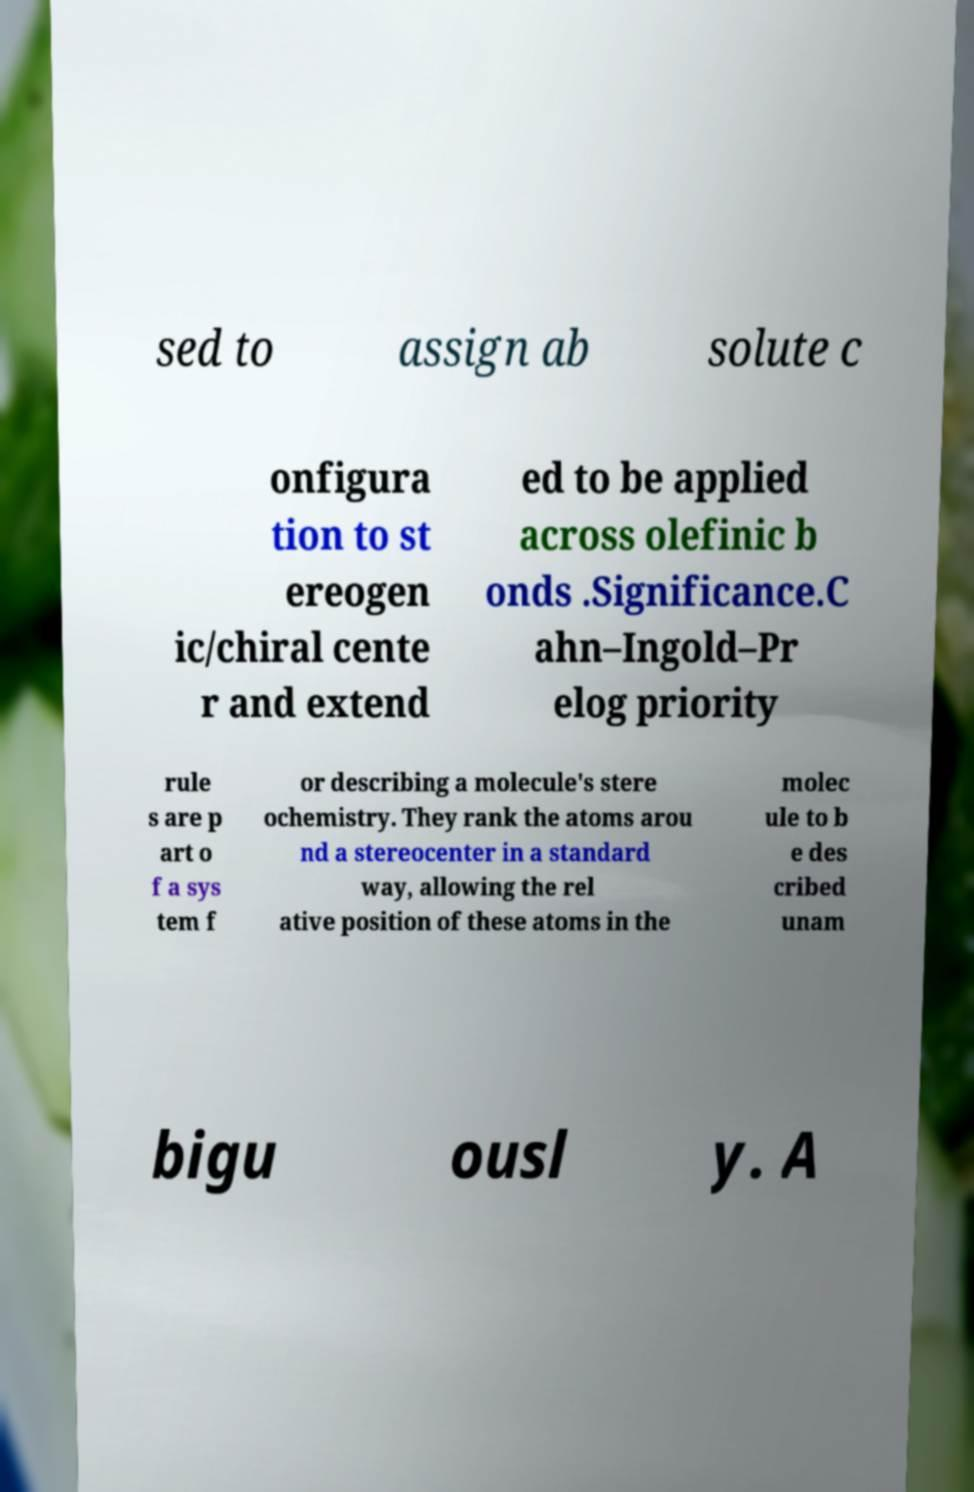Could you extract and type out the text from this image? sed to assign ab solute c onfigura tion to st ereogen ic/chiral cente r and extend ed to be applied across olefinic b onds .Significance.C ahn–Ingold–Pr elog priority rule s are p art o f a sys tem f or describing a molecule's stere ochemistry. They rank the atoms arou nd a stereocenter in a standard way, allowing the rel ative position of these atoms in the molec ule to b e des cribed unam bigu ousl y. A 